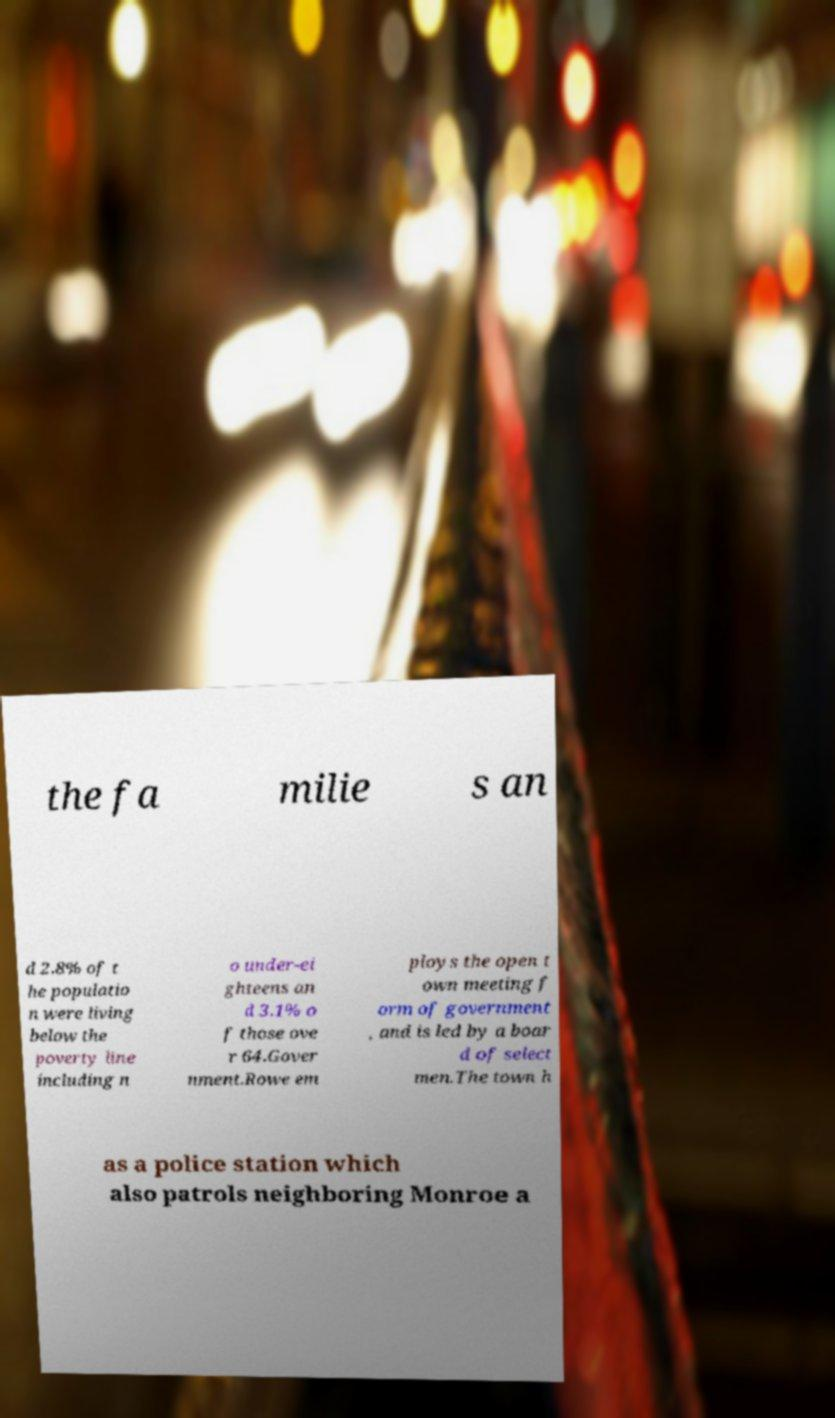For documentation purposes, I need the text within this image transcribed. Could you provide that? the fa milie s an d 2.8% of t he populatio n were living below the poverty line including n o under-ei ghteens an d 3.1% o f those ove r 64.Gover nment.Rowe em ploys the open t own meeting f orm of government , and is led by a boar d of select men.The town h as a police station which also patrols neighboring Monroe a 